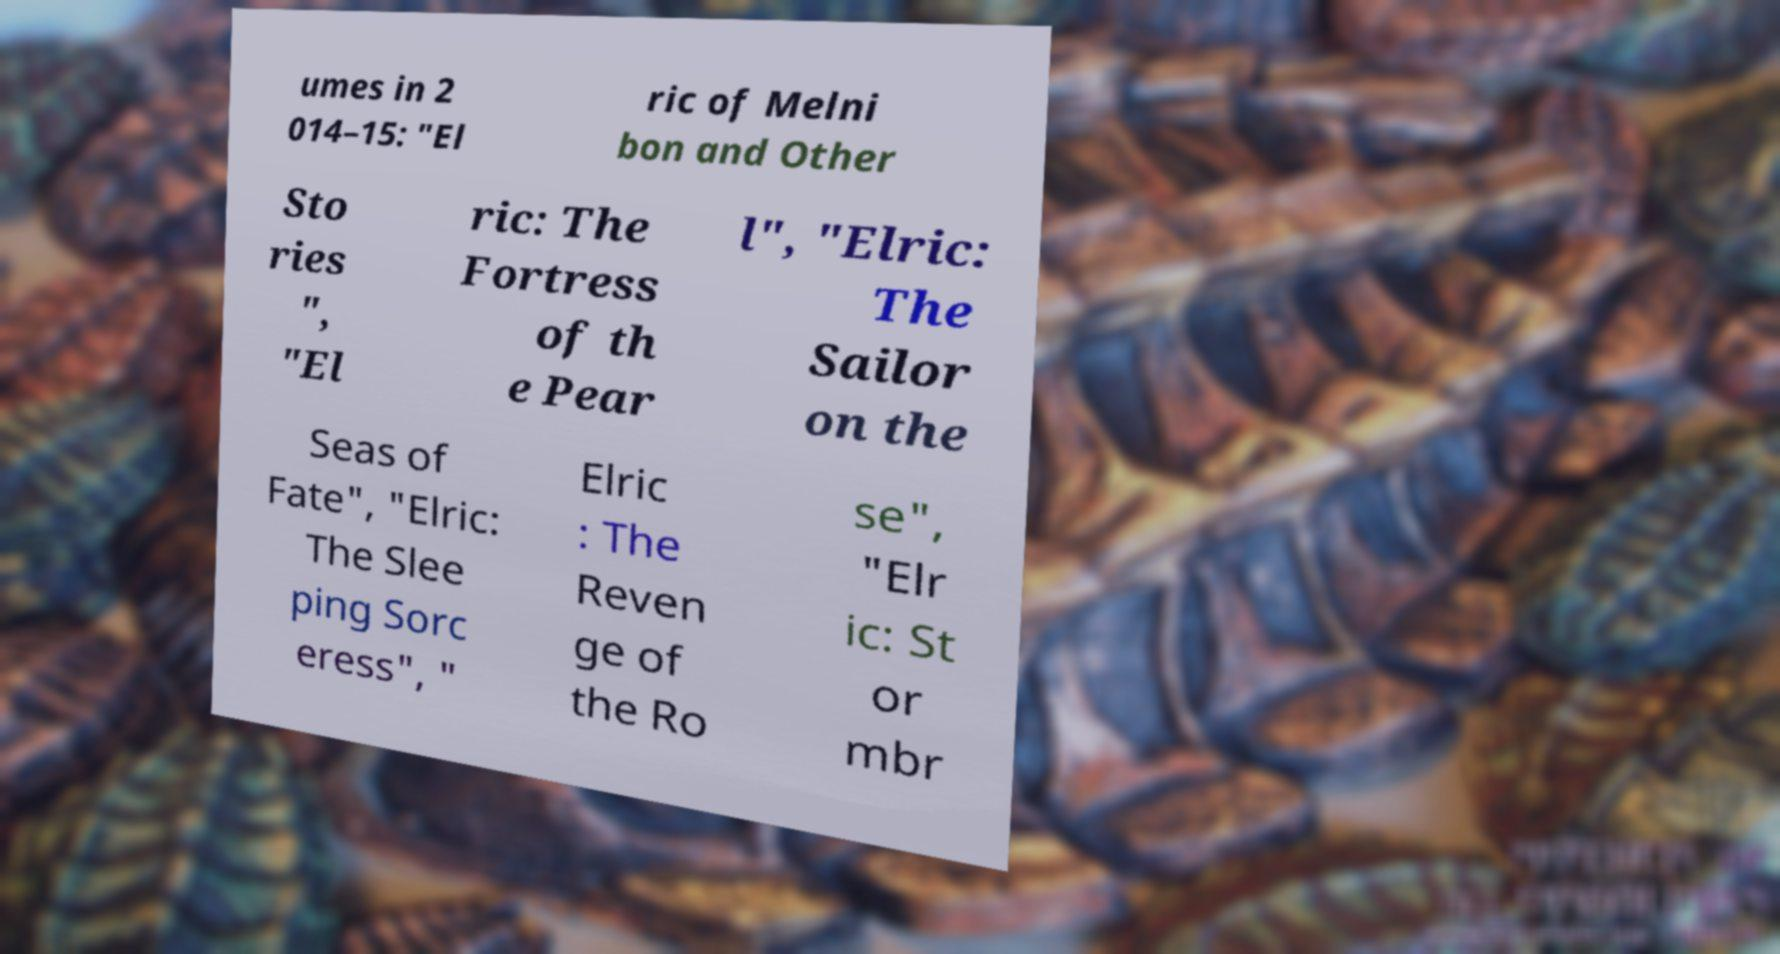For documentation purposes, I need the text within this image transcribed. Could you provide that? umes in 2 014–15: "El ric of Melni bon and Other Sto ries ", "El ric: The Fortress of th e Pear l", "Elric: The Sailor on the Seas of Fate", "Elric: The Slee ping Sorc eress", " Elric : The Reven ge of the Ro se", "Elr ic: St or mbr 